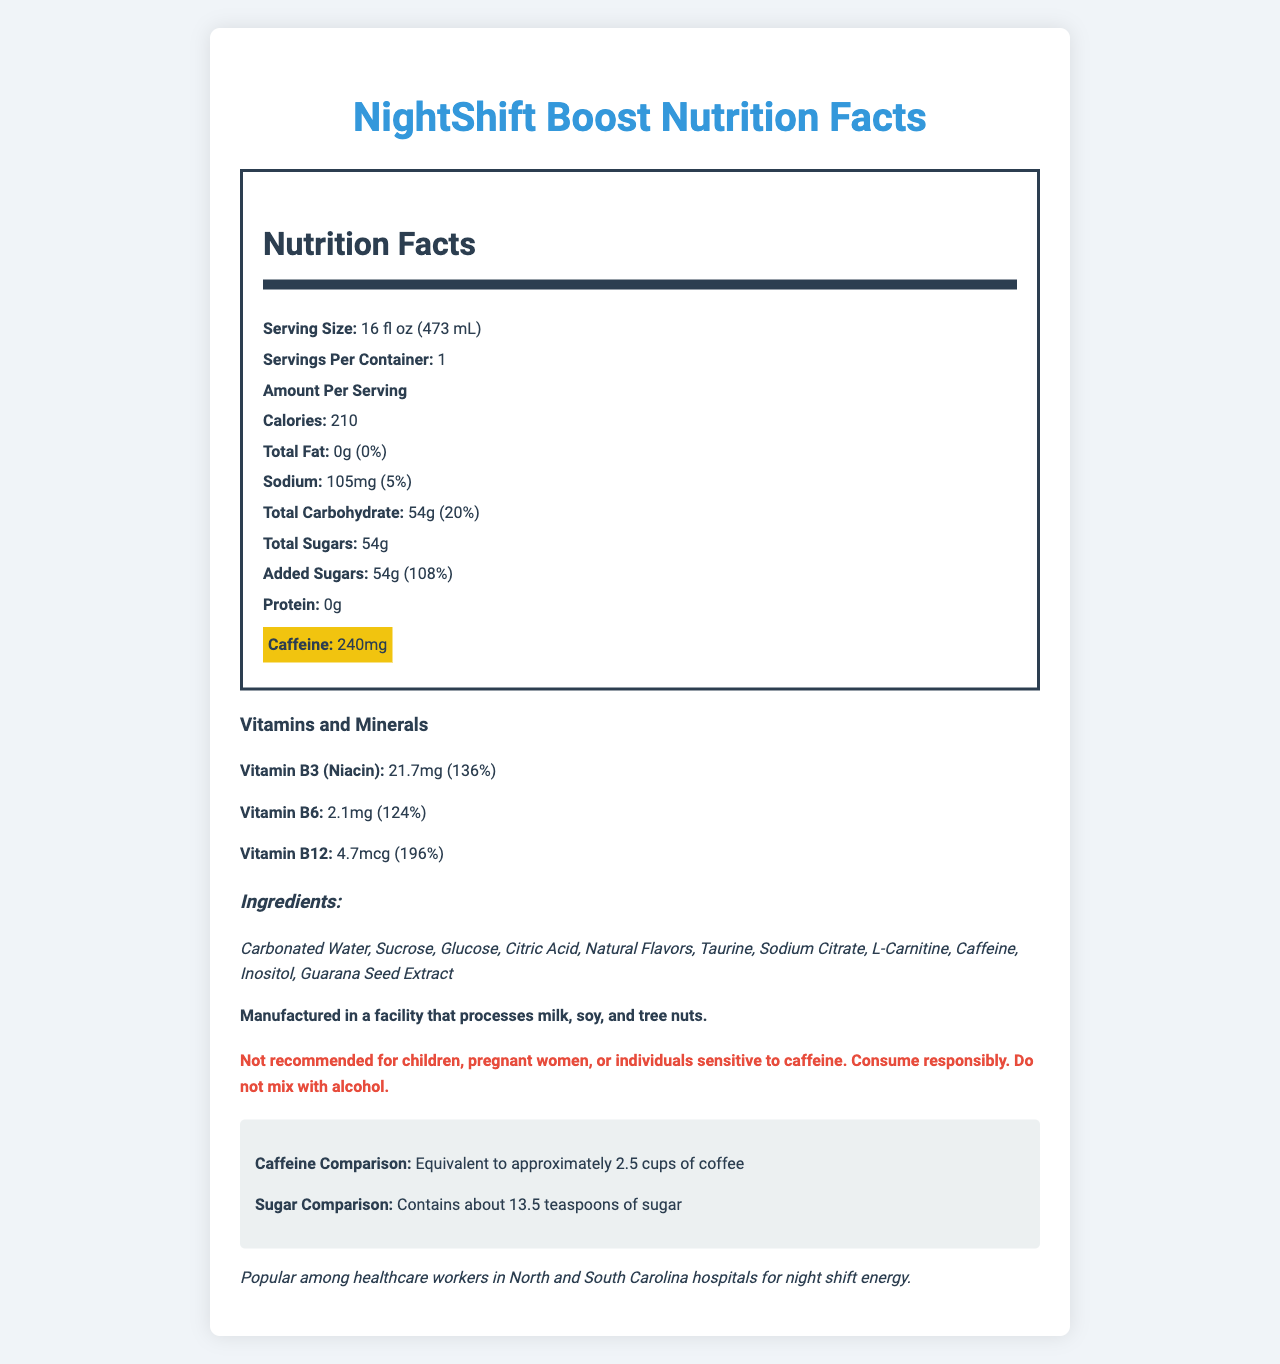what is the serving size of the NightShift Boost energy drink? The serving size is clearly stated as "16 fl oz (473 mL)" in the document.
Answer: 16 fl oz (473 mL) what is the caffeine content per serving? The document highlights "Caffeine: 240mg" in a special highlighted format.
Answer: 240mg how many calories are in one serving of NightShift Boost? The calories per serving are listed as 210 in the document.
Answer: 210 how many grams of sugar does one serving contain? The "Total Sugars" section states that there are 54 grams of sugar per serving.
Answer: 54g what percentage of daily value does the added sugars content represent? The document specifies that the daily value for added sugars is 108%.
Answer: 108% what is the source of the caffeine in NightShift Boost? A. Coffee Beans B. Guarana Seed Extract C. Green Tea Extract The ingredients list includes "Guarana Seed Extract," which is a known source of caffeine.
Answer: B which vitamin is present at the highest percentage of daily value? A. Vitamin B3 B. Vitamin B6 C. Vitamin B12 Vitamin B12 is present at 196% daily value, which is the highest among the listed vitamins.
Answer: C is this product suitable for children? The warning section explicitly states "Not recommended for children."
Answer: No does the beverage contain any protein? The document shows "Protein: 0g," indicating that there is no protein in the beverage.
Answer: No in which states is the NightShift Boost popular among healthcare workers? The regional information notes that the drink is popular in hospitals in North and South Carolina.
Answer: North and South Carolina how does the caffeine content compare to cups of coffee? The document gives the caffeine comparison as "Equivalent to approximately 2.5 cups of coffee."
Answer: Equivalent to approximately 2.5 cups of coffee how many teaspoons of sugar does the NightShift Boost contain? The sugar comparison notes that the product contains about 13.5 teaspoons of sugar.
Answer: About 13.5 teaspoons of sugar describe the main idea of the document. The document showcases various nutrition facts, warnings, and additional information about the NightShift Boost energy drink targeting night shift healthcare workers.
Answer: The document provides detailed nutrition information about the NightShift Boost energy drink, highlighting its caffeine content, sugar levels, and vitamins. It includes warnings and ingredient details. how many servings are in one container? The document clearly states that there is 1 serving per container.
Answer: 1 what is the amount of sodium present in one serving of NightShift Boost? The sodium content is mentioned as 105mg, making up 5% of the daily value.
Answer: 105mg what is the total carbohydrate content and its daily value percentage? The document indicates that the total carbohydrate content is 54g, which is 20% of the daily value.
Answer: 54g, 20% is it recommended to mix this drink with alcohol? The document clearly warns against mixing the energy drink with alcohol.
Answer: No is the product manufactured in a facility that processes gluten? The allergen information does not mention gluten, only milk, soy, and tree nuts.
Answer: Not enough information 